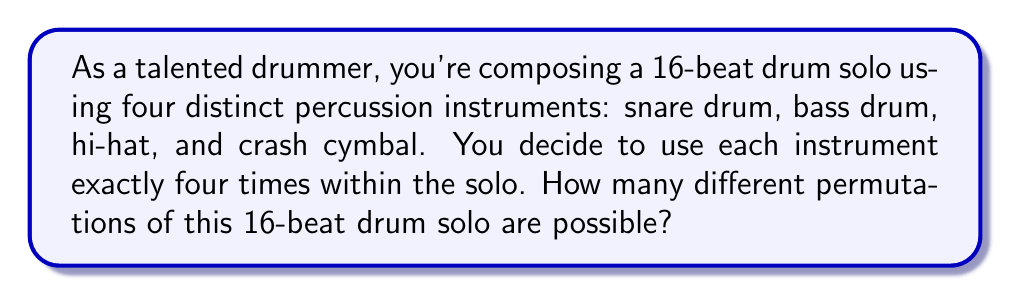Can you solve this math problem? Let's approach this step-by-step:

1) First, we need to understand that this is a permutation problem with repetition. We have 16 total beats, and each of the four instruments is used exactly four times.

2) This scenario can be modeled using the multinomial coefficient formula. The multinomial coefficient calculates the number of ways to arrange $n$ items into $k$ groups, where each group $i$ contains $n_i$ items.

3) The formula for the multinomial coefficient is:

   $$\binom{n}{n_1, n_2, ..., n_k} = \frac{n!}{n_1! \cdot n_2! \cdot ... \cdot n_k!}$$

4) In our case:
   - $n = 16$ (total number of beats)
   - $k = 4$ (number of instruments)
   - $n_1 = n_2 = n_3 = n_4 = 4$ (each instrument is used 4 times)

5) Plugging these values into the formula:

   $$\binom{16}{4, 4, 4, 4} = \frac{16!}{4! \cdot 4! \cdot 4! \cdot 4!}$$

6) Let's calculate this:
   
   $$\frac{16!}{(4!)^4} = \frac{20,922,789,888,000}{24^4} = \frac{20,922,789,888,000}{331,776} = 63,063,000$$

Therefore, there are 63,063,000 possible permutations of this 16-beat drum solo.
Answer: 63,063,000 permutations 